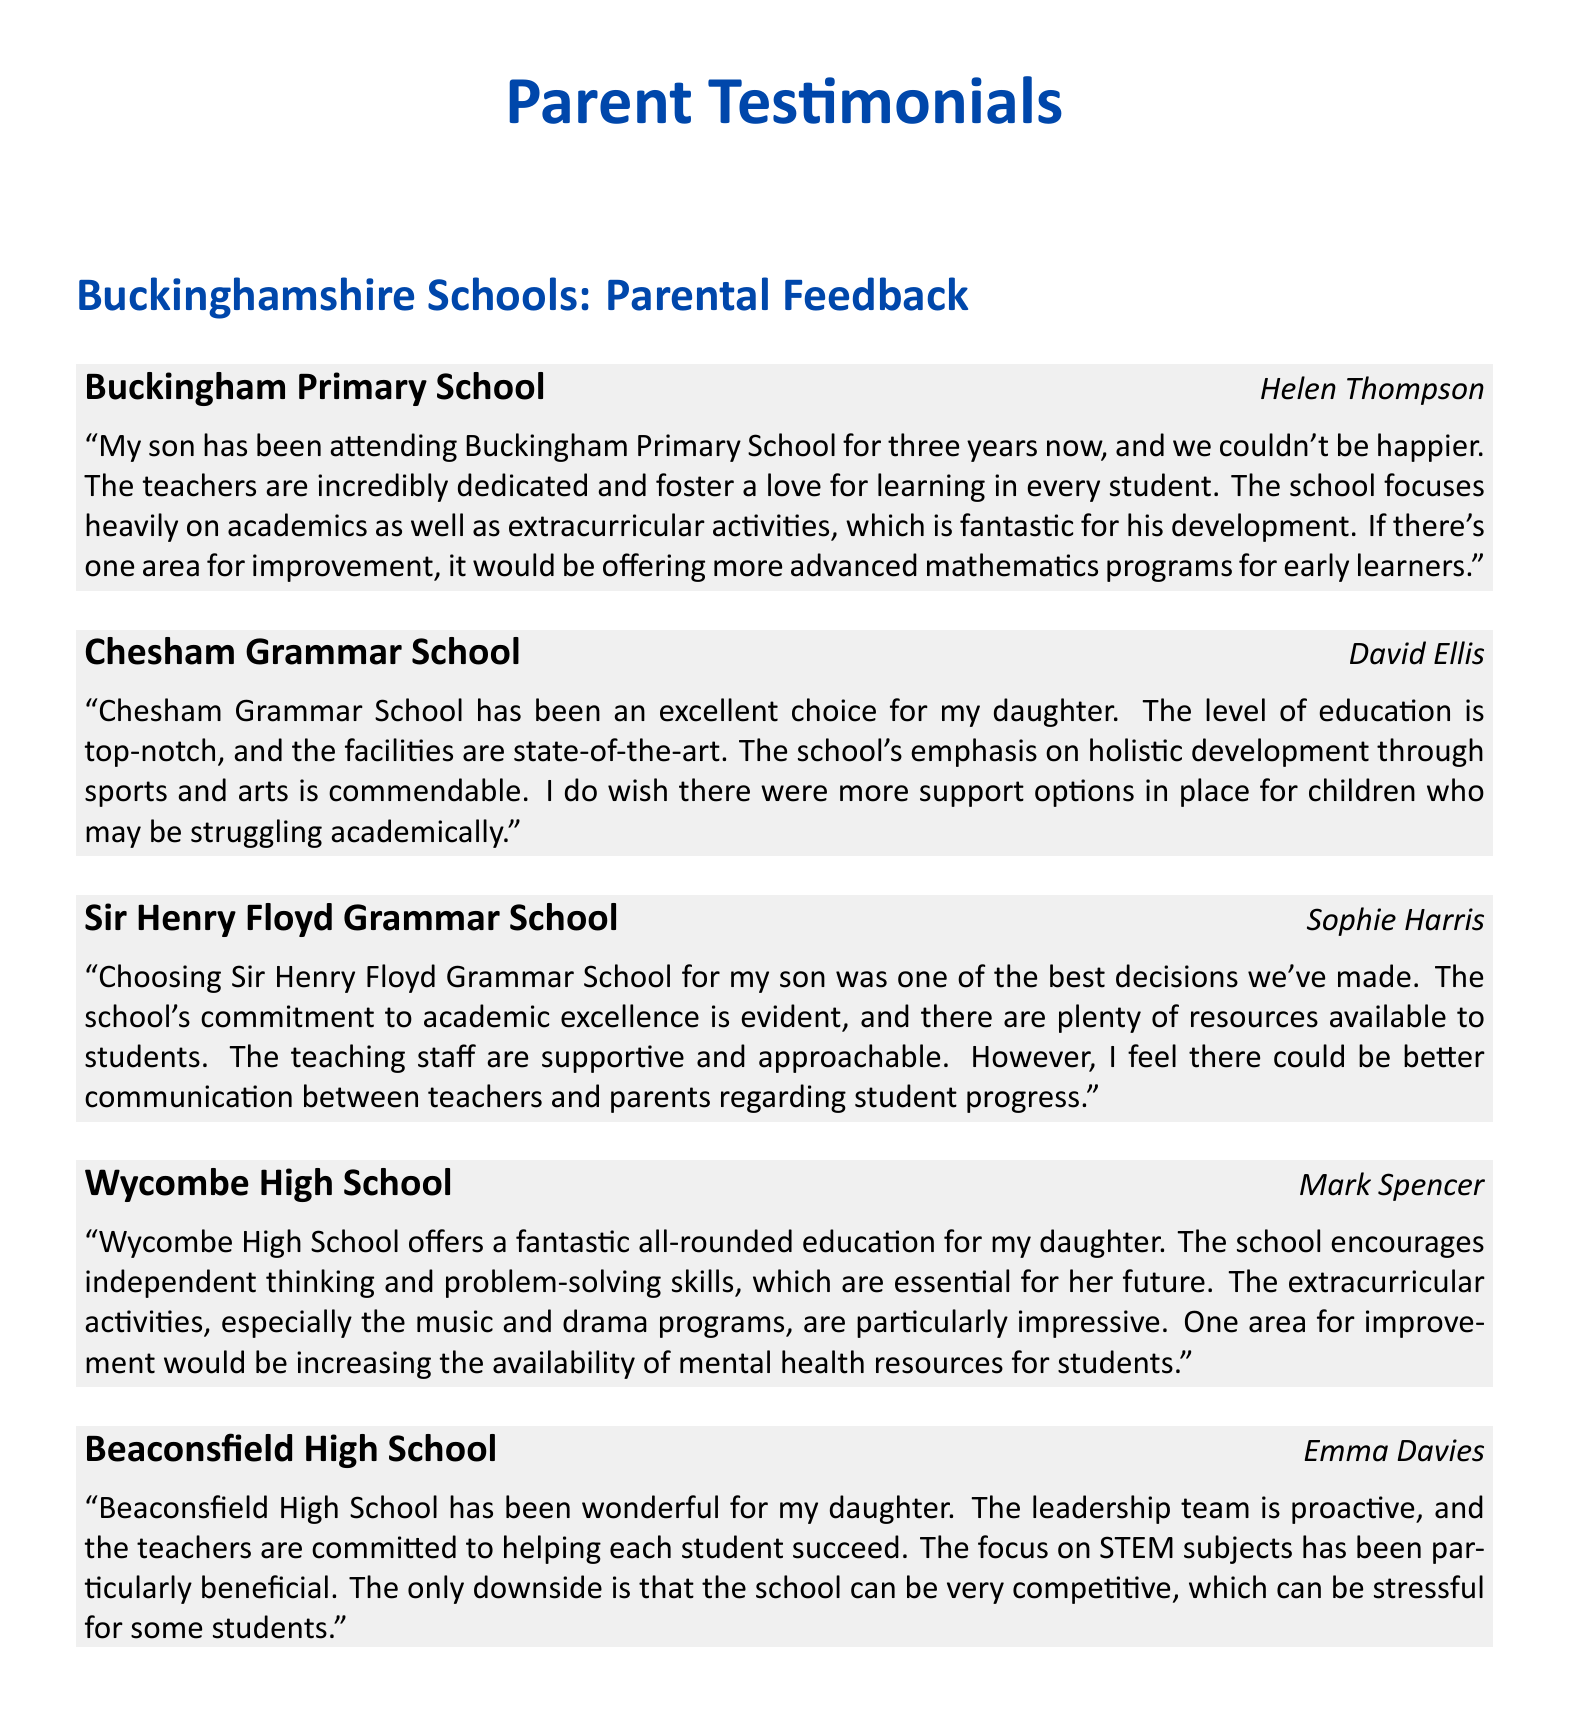What is the name of the school reviewed by Helen Thompson? Helen Thompson reviewed Buckingham Primary School.
Answer: Buckingham Primary School How long has Helen Thompson's son been attending his school? Helen Thompson's son has been attending for three years.
Answer: Three years What subject area does David Ellis wish had more support options at Chesham Grammar School? David Ellis wishes there were more support options for struggling children academically.
Answer: Academically What does Sophie Harris feel could be improved at Sir Henry Floyd Grammar School? Sophie Harris feels that communication regarding student progress could be improved.
Answer: Communication with parents Which extracurricular activities at Wycombe High School are highlighted as impressive? The music and drama programs are particularly impressive.
Answer: Music and drama programs What competitive aspect does Emma Davies mention about Beaconsfield High School? Emma Davies mentions that the school can be very competitive, leading to stress for some students.
Answer: Competitive environment What is the key focus area noted by Emma Davies for her daughter's education at Beaconsfield High School? The focus on STEM subjects is noted as particularly beneficial.
Answer: STEM subjects Which school has a state-of-the-art facility according to David Ellis? Chesham Grammar School is described as having state-of-the-art facilities.
Answer: Chesham Grammar School What is one of the strengths mentioned by Mark Spencer about Wycombe High School's education? Mark Spencer mentions that the school encourages independent thinking and problem-solving skills.
Answer: Independent thinking and problem-solving skills 